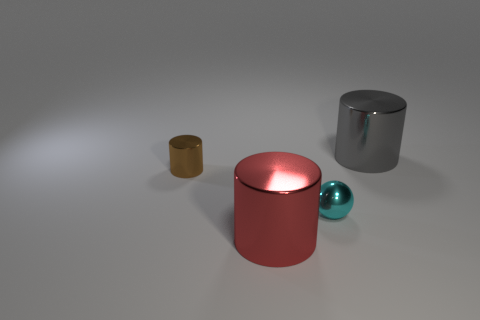Subtract all gray metallic cylinders. How many cylinders are left? 2 Add 4 big gray cylinders. How many objects exist? 8 Subtract all brown cylinders. How many cylinders are left? 2 Subtract all cylinders. How many objects are left? 1 Subtract all green cylinders. Subtract all green blocks. How many cylinders are left? 3 Add 4 large things. How many large things are left? 6 Add 2 red cylinders. How many red cylinders exist? 3 Subtract 0 gray spheres. How many objects are left? 4 Subtract all large blue metal spheres. Subtract all cylinders. How many objects are left? 1 